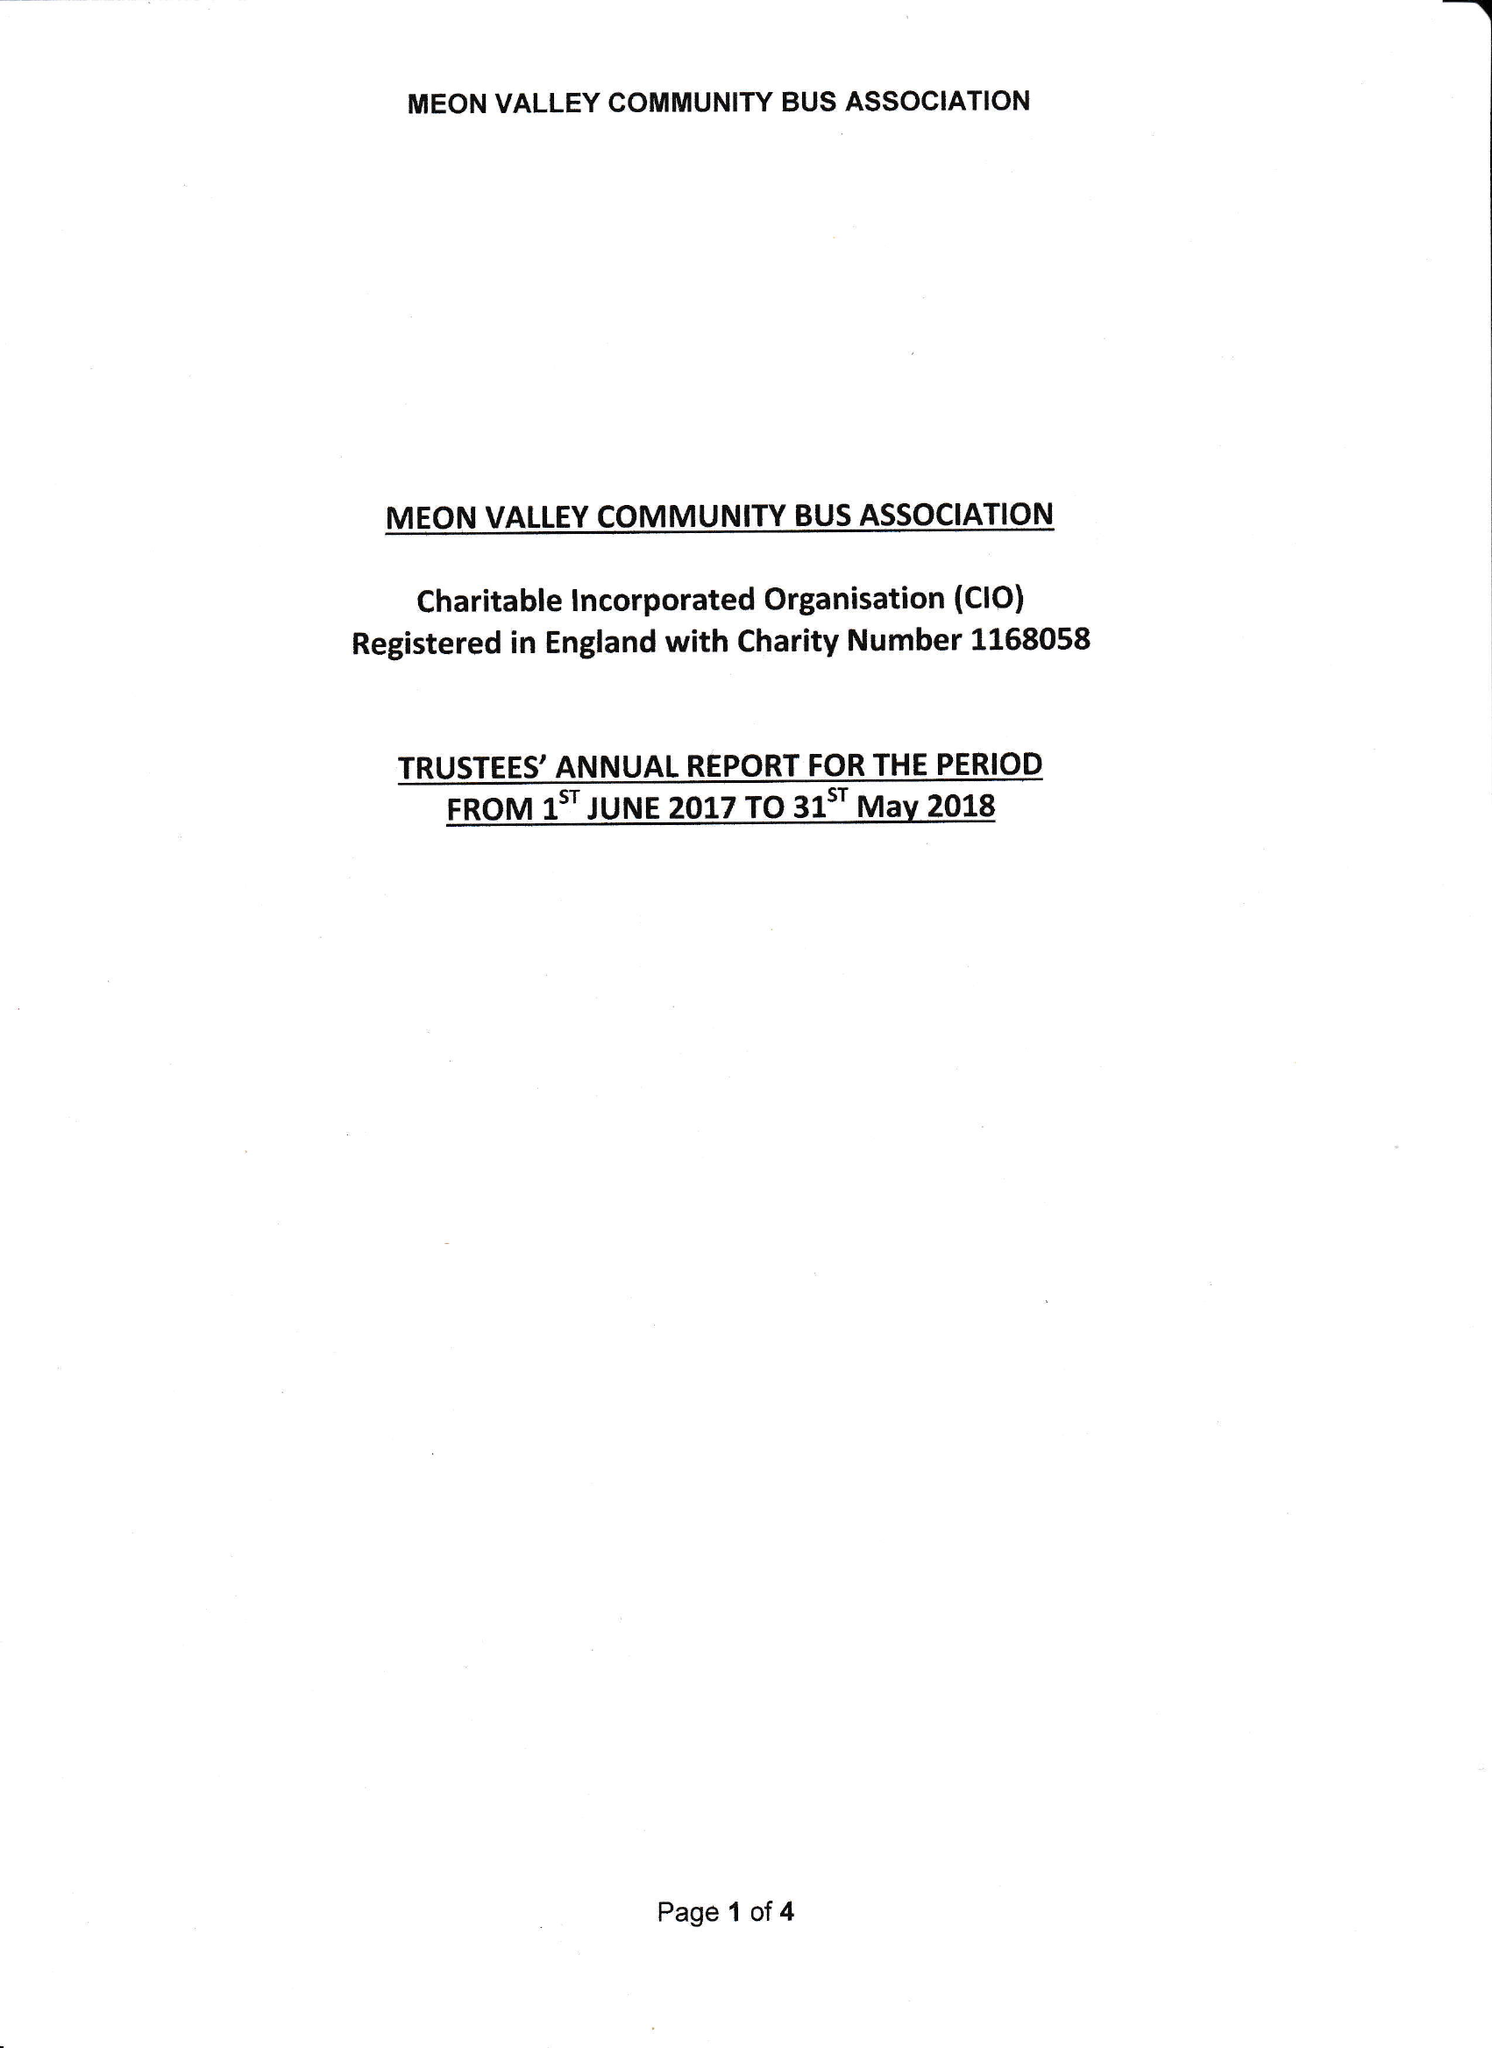What is the value for the address__postcode?
Answer the question using a single word or phrase. SO32 3QU 